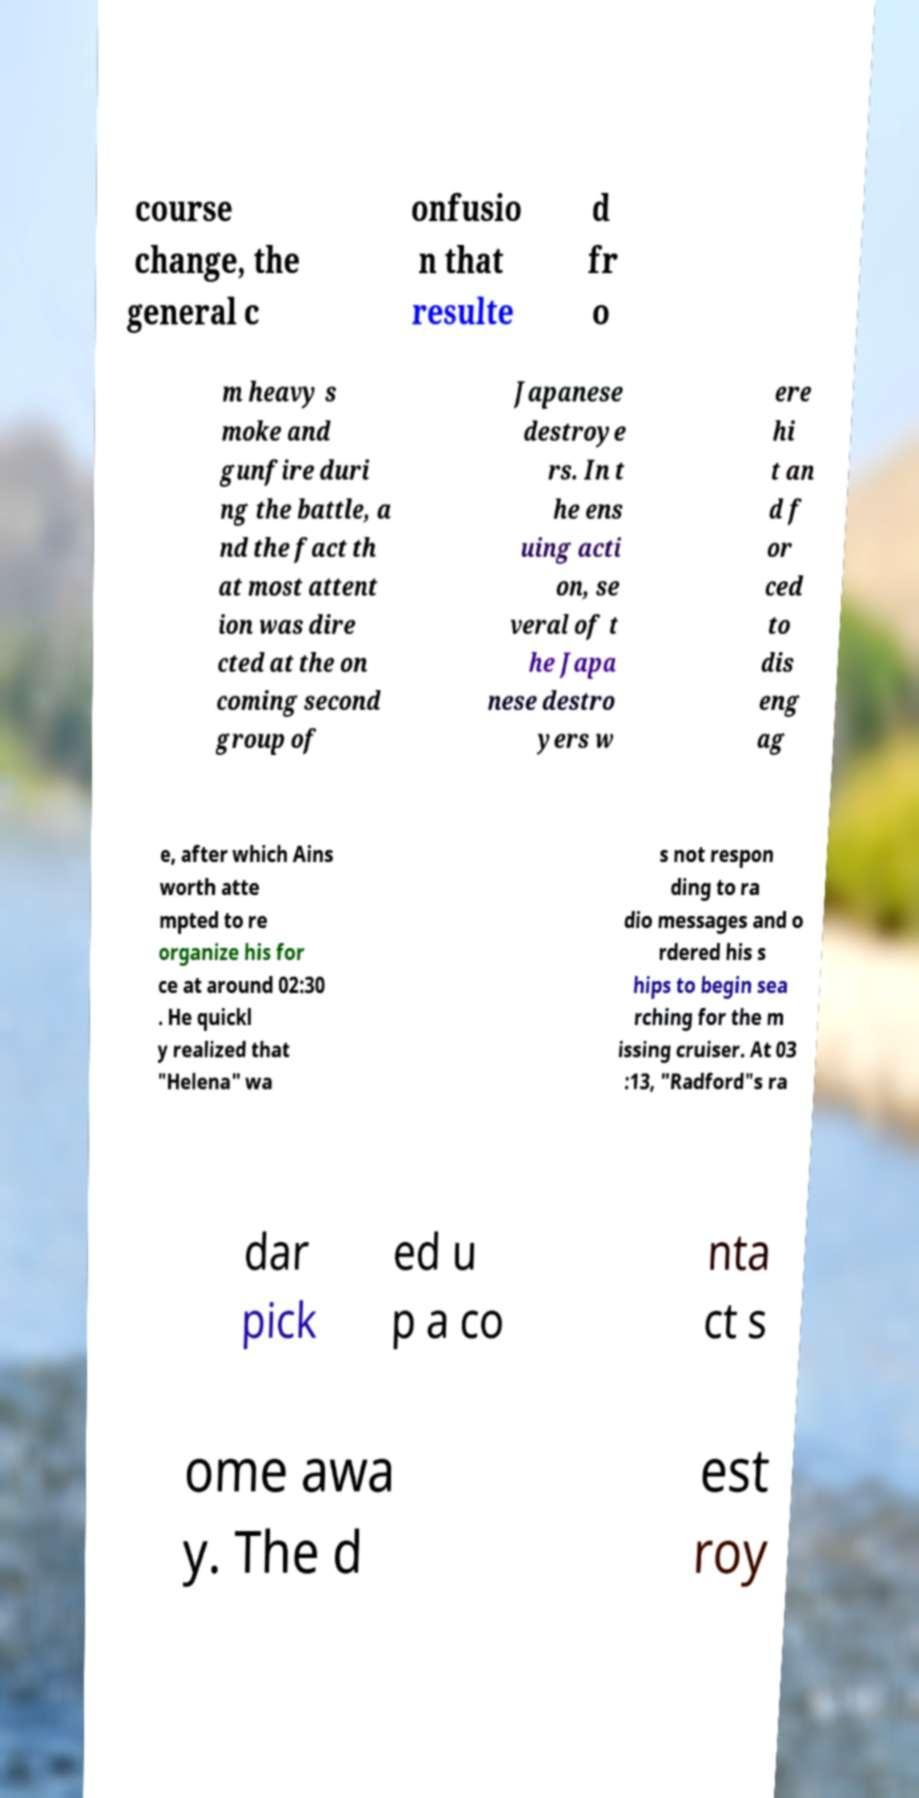I need the written content from this picture converted into text. Can you do that? course change, the general c onfusio n that resulte d fr o m heavy s moke and gunfire duri ng the battle, a nd the fact th at most attent ion was dire cted at the on coming second group of Japanese destroye rs. In t he ens uing acti on, se veral of t he Japa nese destro yers w ere hi t an d f or ced to dis eng ag e, after which Ains worth atte mpted to re organize his for ce at around 02:30 . He quickl y realized that "Helena" wa s not respon ding to ra dio messages and o rdered his s hips to begin sea rching for the m issing cruiser. At 03 :13, "Radford"s ra dar pick ed u p a co nta ct s ome awa y. The d est roy 